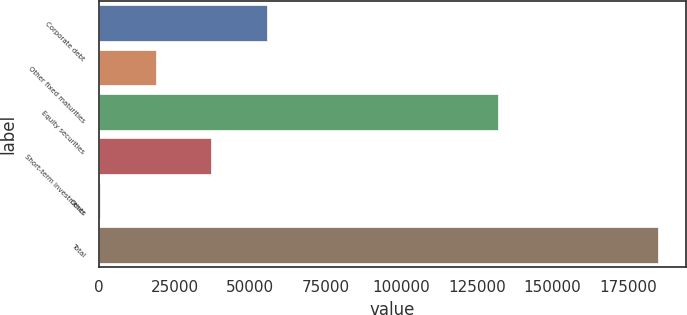Convert chart to OTSL. <chart><loc_0><loc_0><loc_500><loc_500><bar_chart><fcel>Corporate debt<fcel>Other fixed maturities<fcel>Equity securities<fcel>Short-term investments<fcel>Other<fcel>Total<nl><fcel>55626<fcel>18728<fcel>131846<fcel>37177<fcel>279<fcel>184769<nl></chart> 